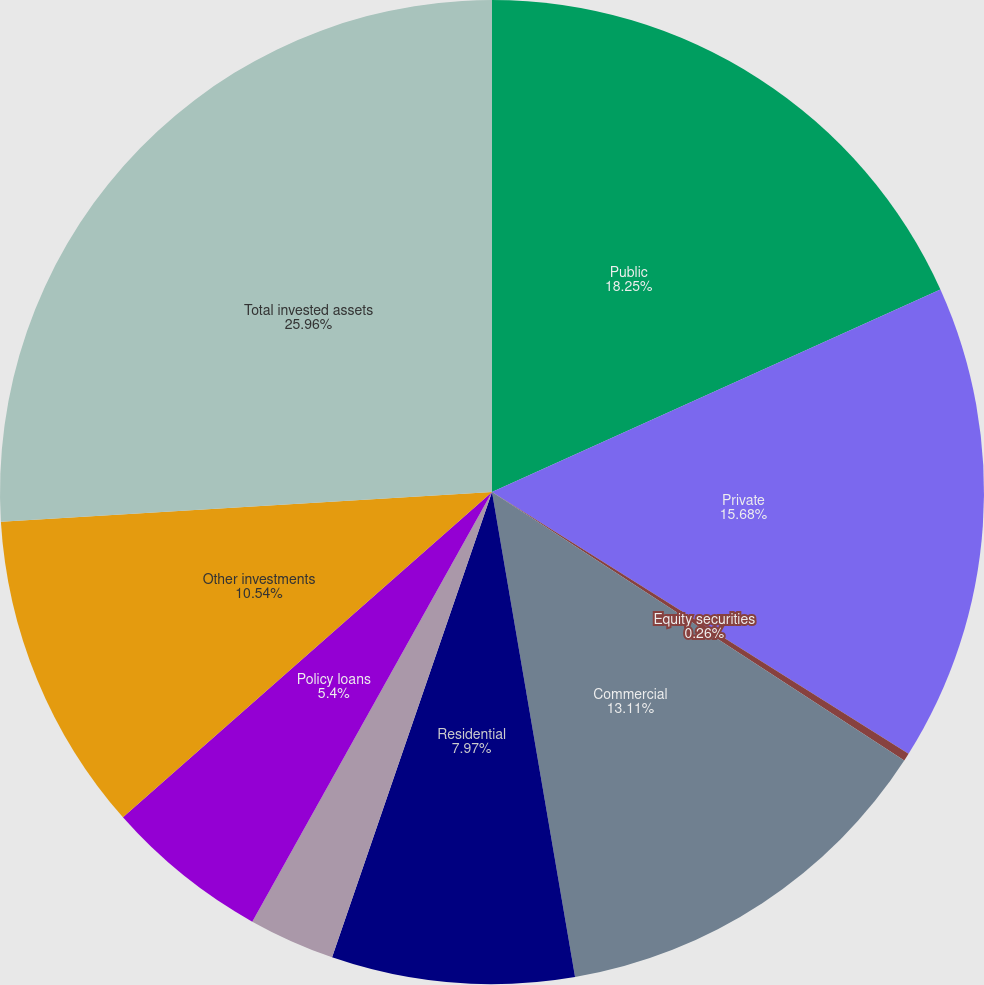Convert chart. <chart><loc_0><loc_0><loc_500><loc_500><pie_chart><fcel>Public<fcel>Private<fcel>Equity securities<fcel>Commercial<fcel>Residential<fcel>Real estate held for<fcel>Policy loans<fcel>Other investments<fcel>Total invested assets<nl><fcel>18.25%<fcel>15.68%<fcel>0.26%<fcel>13.11%<fcel>7.97%<fcel>2.83%<fcel>5.4%<fcel>10.54%<fcel>25.96%<nl></chart> 